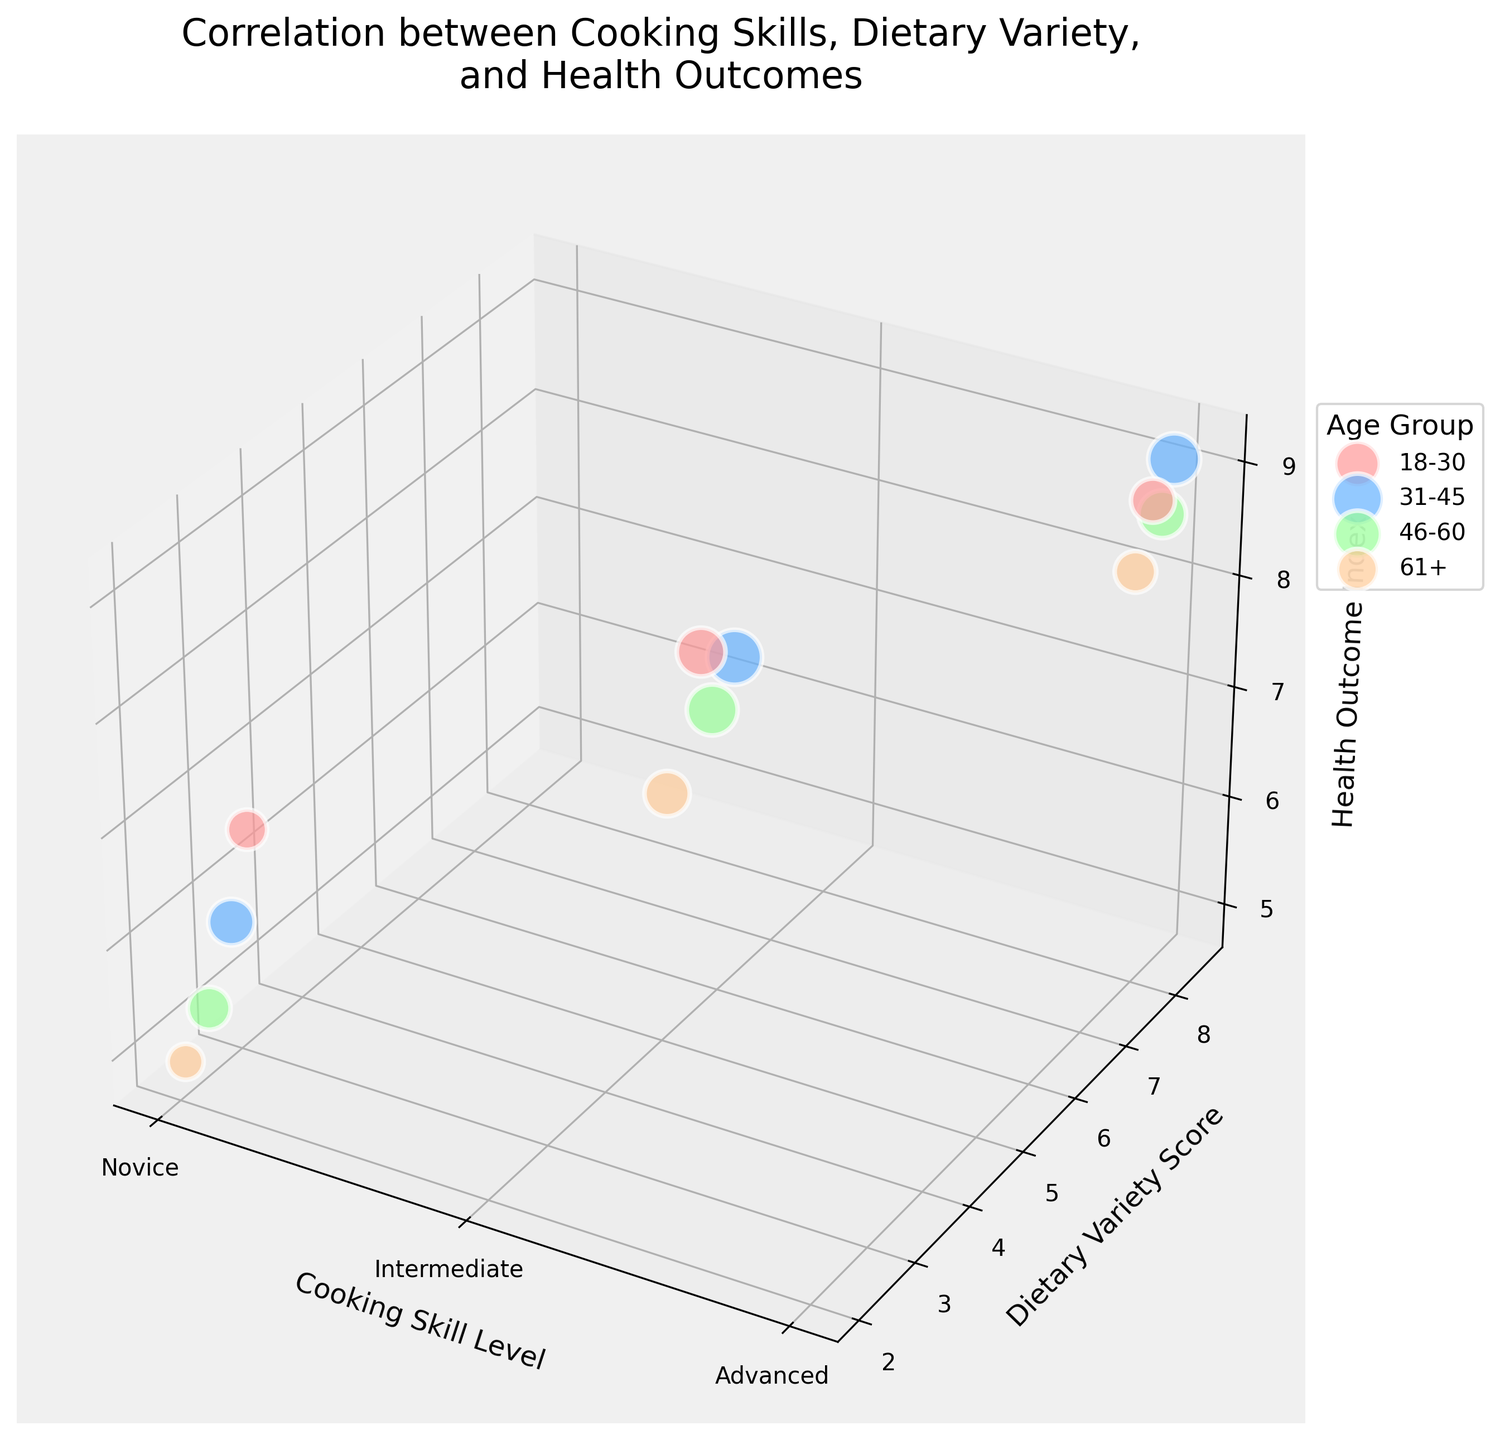What's the title of the figure? The title of the figure is displayed at the top of the chart. It is usually concise and explains the main focus of the figure. Here, it reads "Correlation between Cooking Skills, Dietary Variety, and Health Outcomes."
Answer: Correlation between Cooking Skills, Dietary Variety, and Health Outcomes How is the Cooking Skill Level represented on the x-axis? The x-axis uses markers at positions 1, 2, and 3 to represent Cooking Skill Levels. These are labeled as Novice, Intermediate, and Advanced, respectively.
Answer: Novice, Intermediate, Advanced Which age group has the largest bubble size? Look at the different colors representing age groups and compare the sizes of bubbles. The bubbles for the age group 31-45 are generally the largest. The Intermediate level in this group, for instance, is very large.
Answer: 31-45 What is the relationship between Cooking Skill Level and Health Outcome Index for the 18-30 age group? Survey the data points labeled with the color for the 18-30 age group along the Health Outcome Index (z-axis). Notice that as the Cooking Skill Level increases (Novice to Advanced), the Health Outcome Index also increases.
Answer: Positive correlation Which age group shows the highest Health Outcome Index at the Advanced cooking skill level? Look at the Advanced cooking skill level data points and compare the z-values (Health Outcome Index) across different age groups. The group 31-45 color-coded data point is more elevated on the z-axis.
Answer: 31-45 Among the "Novice" cooking skill level data points, which age group has the lowest Dietary Variety Score? Compare the Novice-level bubbles across the y-axis (Dietary Variety Score). The bubble for age group 61+ shows a noticeably low Dietary Variety Score.
Answer: 61+ How does the Dietary Variety Score for Intermediate cooks in the 46-60 age group compare to that of the Novice cooks in the same age group? Check the bubbles for the 46-60 age group and compare their positions along the y-axis. Intermediate cooks have a Dietary Variety Score of 5.9, higher than Novice cooks, who have a score of 2.5.
Answer: Higher What can be inferred about Health Outcome Index trends across different Cooking Skill Levels and age groups? Survey the chart to see the general trend in z-axis values when moving from Novice to Advanced across different age groups. Generally, higher Cooking Skill Levels correspond to higher Health Outcome Indexes across all age groups.
Answer: Higher skill correlates with better health Which two age groups have the closest Dietary Variety Scores for the Intermediate cooking skill level? Look at the y-axis positions of bubbles that represent the Intermediate level for all age groups. The 18-30 and 46-60 age groups have close scores, with scores of 5.7 and 5.9, respectively.
Answer: 18-30 and 46-60 What trend do you notice between age groups and bubble sizes for each cooking skill level? Observe the pattern in bubble sizes for different age groups with the same Cooking Skill Level. Generally, the bubbles seem to get larger as the age group progresses from 18-30 to 31-45 and then slightly decrease as the age group gets older (46-60 and 61+).
Answer: Largest around 31-45 then decreases 